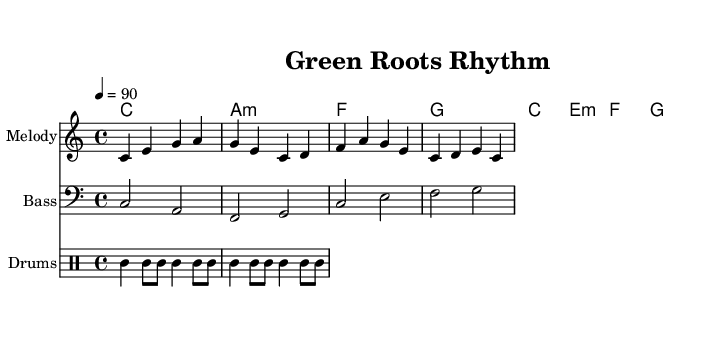What is the key signature of this music? The key signature is C major, which is indicated by the absence of sharps or flats. The notation indicates that the music is based on the C major scale.
Answer: C major What is the time signature of this piece? The time signature is 4/4, denoted at the beginning of the score. This indicates there are four beats in each measure and the quarter note gets one beat.
Answer: 4/4 What is the tempo marking for this composition? The tempo marking is 90 beats per minute, denoted by the tempo indication "4 = 90" at the beginning of the score. This specifies how fast the piece should be played.
Answer: 90 What type of bass clef is used in this piece? The bass clef used is the standard bass clef, which allows for the notation of lower pitches; it is indicated at the beginning of the bass staff.
Answer: Bass clef Which organic instrument sounds might be represented in the arrangement? The arrangement includes a fusion of organic sounds, suggesting instruments like drums, possibly acoustic or hand-played to create a natural feel, paired with the reggae style.
Answer: Drums How does the chord progression support the reggae style? The chord progression (C, A minor, F, G) is characteristic of reggae music, providing a laid-back, rhythmic foundation typical in this genre, contributing to its distinct sound.
Answer: C, A minor, F, G 